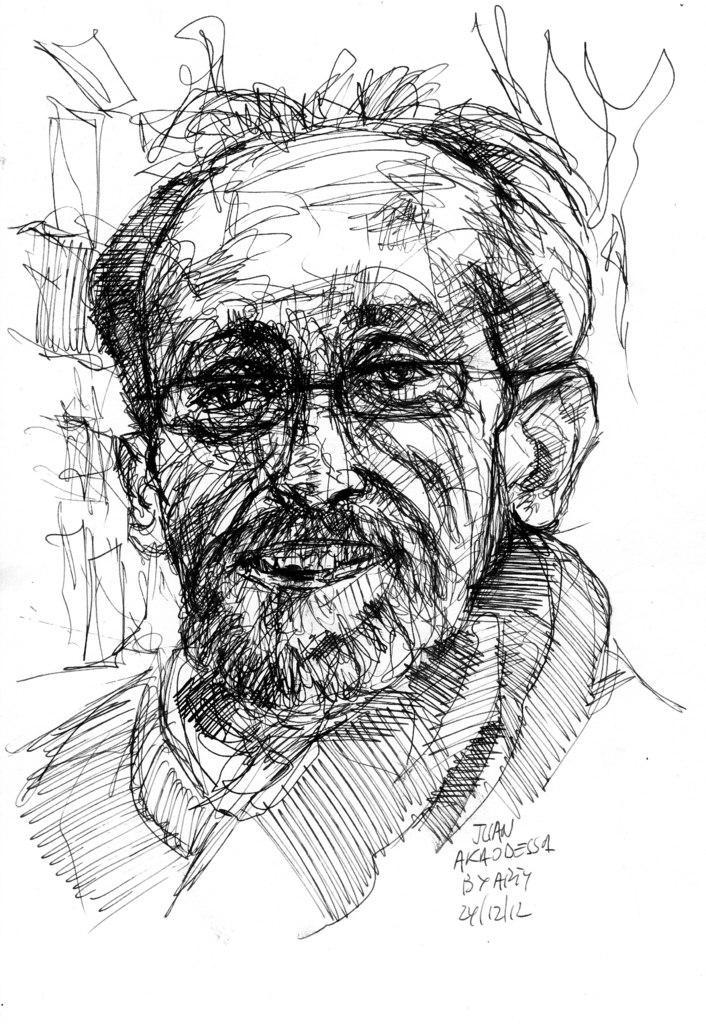Can you describe this image briefly? In this picture we can see drawing of a man and we can see text. In the background of the image it is white. 